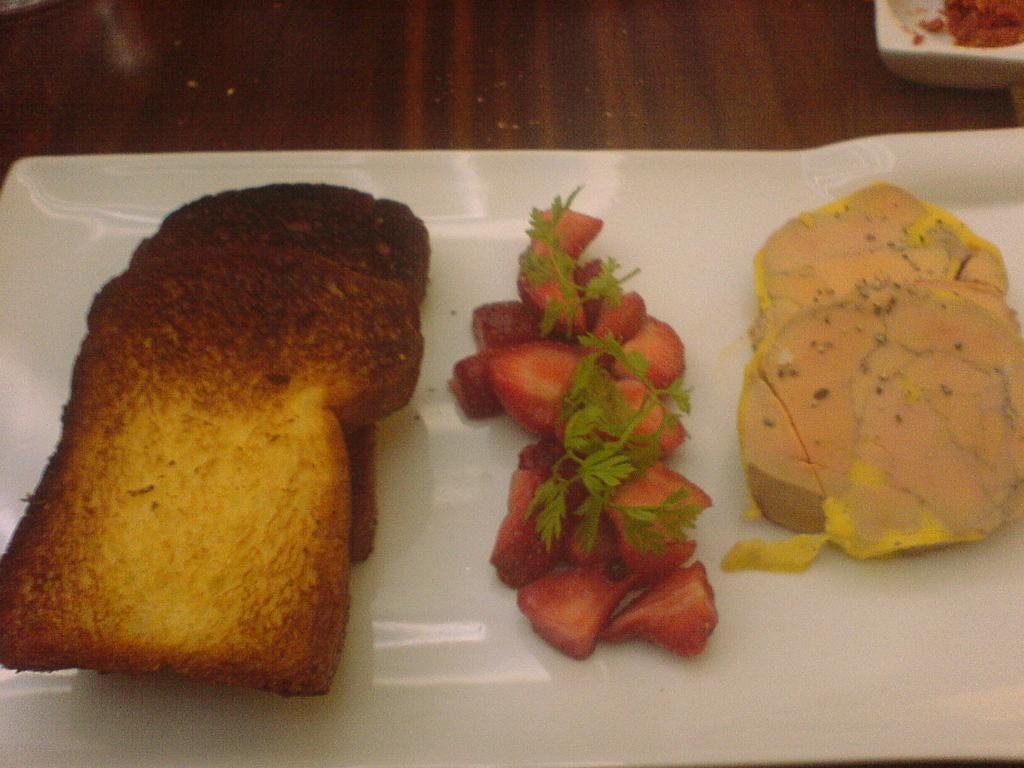What is on the plate that is visible in the image? There are toasted breads and strawberries with leaves on the plate. What color is the plate in the image? The plate is white. Where is the plate located in the image? The plate is on a surface. Can you describe the unspecified food item on the plate? Unfortunately, the fact does not specify the details of the unspecified food item on the plate. What is the opinion of the strawberries on the plate? Strawberries do not have opinions, as they are inanimate objects. 